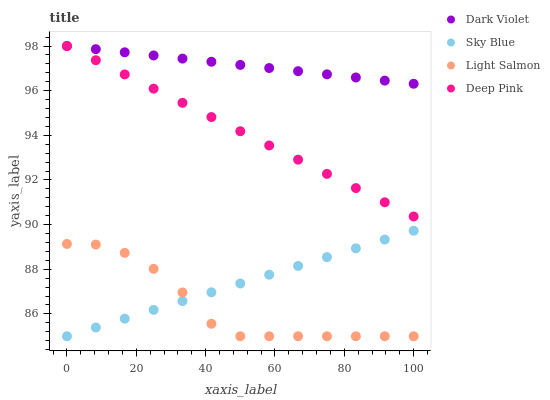Does Light Salmon have the minimum area under the curve?
Answer yes or no. Yes. Does Dark Violet have the maximum area under the curve?
Answer yes or no. Yes. Does Deep Pink have the minimum area under the curve?
Answer yes or no. No. Does Deep Pink have the maximum area under the curve?
Answer yes or no. No. Is Sky Blue the smoothest?
Answer yes or no. Yes. Is Light Salmon the roughest?
Answer yes or no. Yes. Is Deep Pink the smoothest?
Answer yes or no. No. Is Deep Pink the roughest?
Answer yes or no. No. Does Sky Blue have the lowest value?
Answer yes or no. Yes. Does Deep Pink have the lowest value?
Answer yes or no. No. Does Dark Violet have the highest value?
Answer yes or no. Yes. Does Light Salmon have the highest value?
Answer yes or no. No. Is Light Salmon less than Deep Pink?
Answer yes or no. Yes. Is Deep Pink greater than Sky Blue?
Answer yes or no. Yes. Does Deep Pink intersect Dark Violet?
Answer yes or no. Yes. Is Deep Pink less than Dark Violet?
Answer yes or no. No. Is Deep Pink greater than Dark Violet?
Answer yes or no. No. Does Light Salmon intersect Deep Pink?
Answer yes or no. No. 